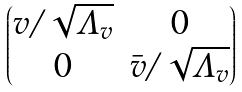Convert formula to latex. <formula><loc_0><loc_0><loc_500><loc_500>\begin{pmatrix} v / \sqrt { \Lambda _ { v } } & 0 \\ 0 & \bar { v } / \sqrt { \Lambda _ { v } } \end{pmatrix}</formula> 